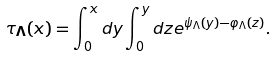<formula> <loc_0><loc_0><loc_500><loc_500>\tau _ { \mathbf \Lambda } ( x ) = \int _ { 0 } ^ { x } d y \int _ { 0 } ^ { y } d z e ^ { \psi _ { \Lambda } ( y ) - \varphi _ { \Lambda } ( z ) } .</formula> 